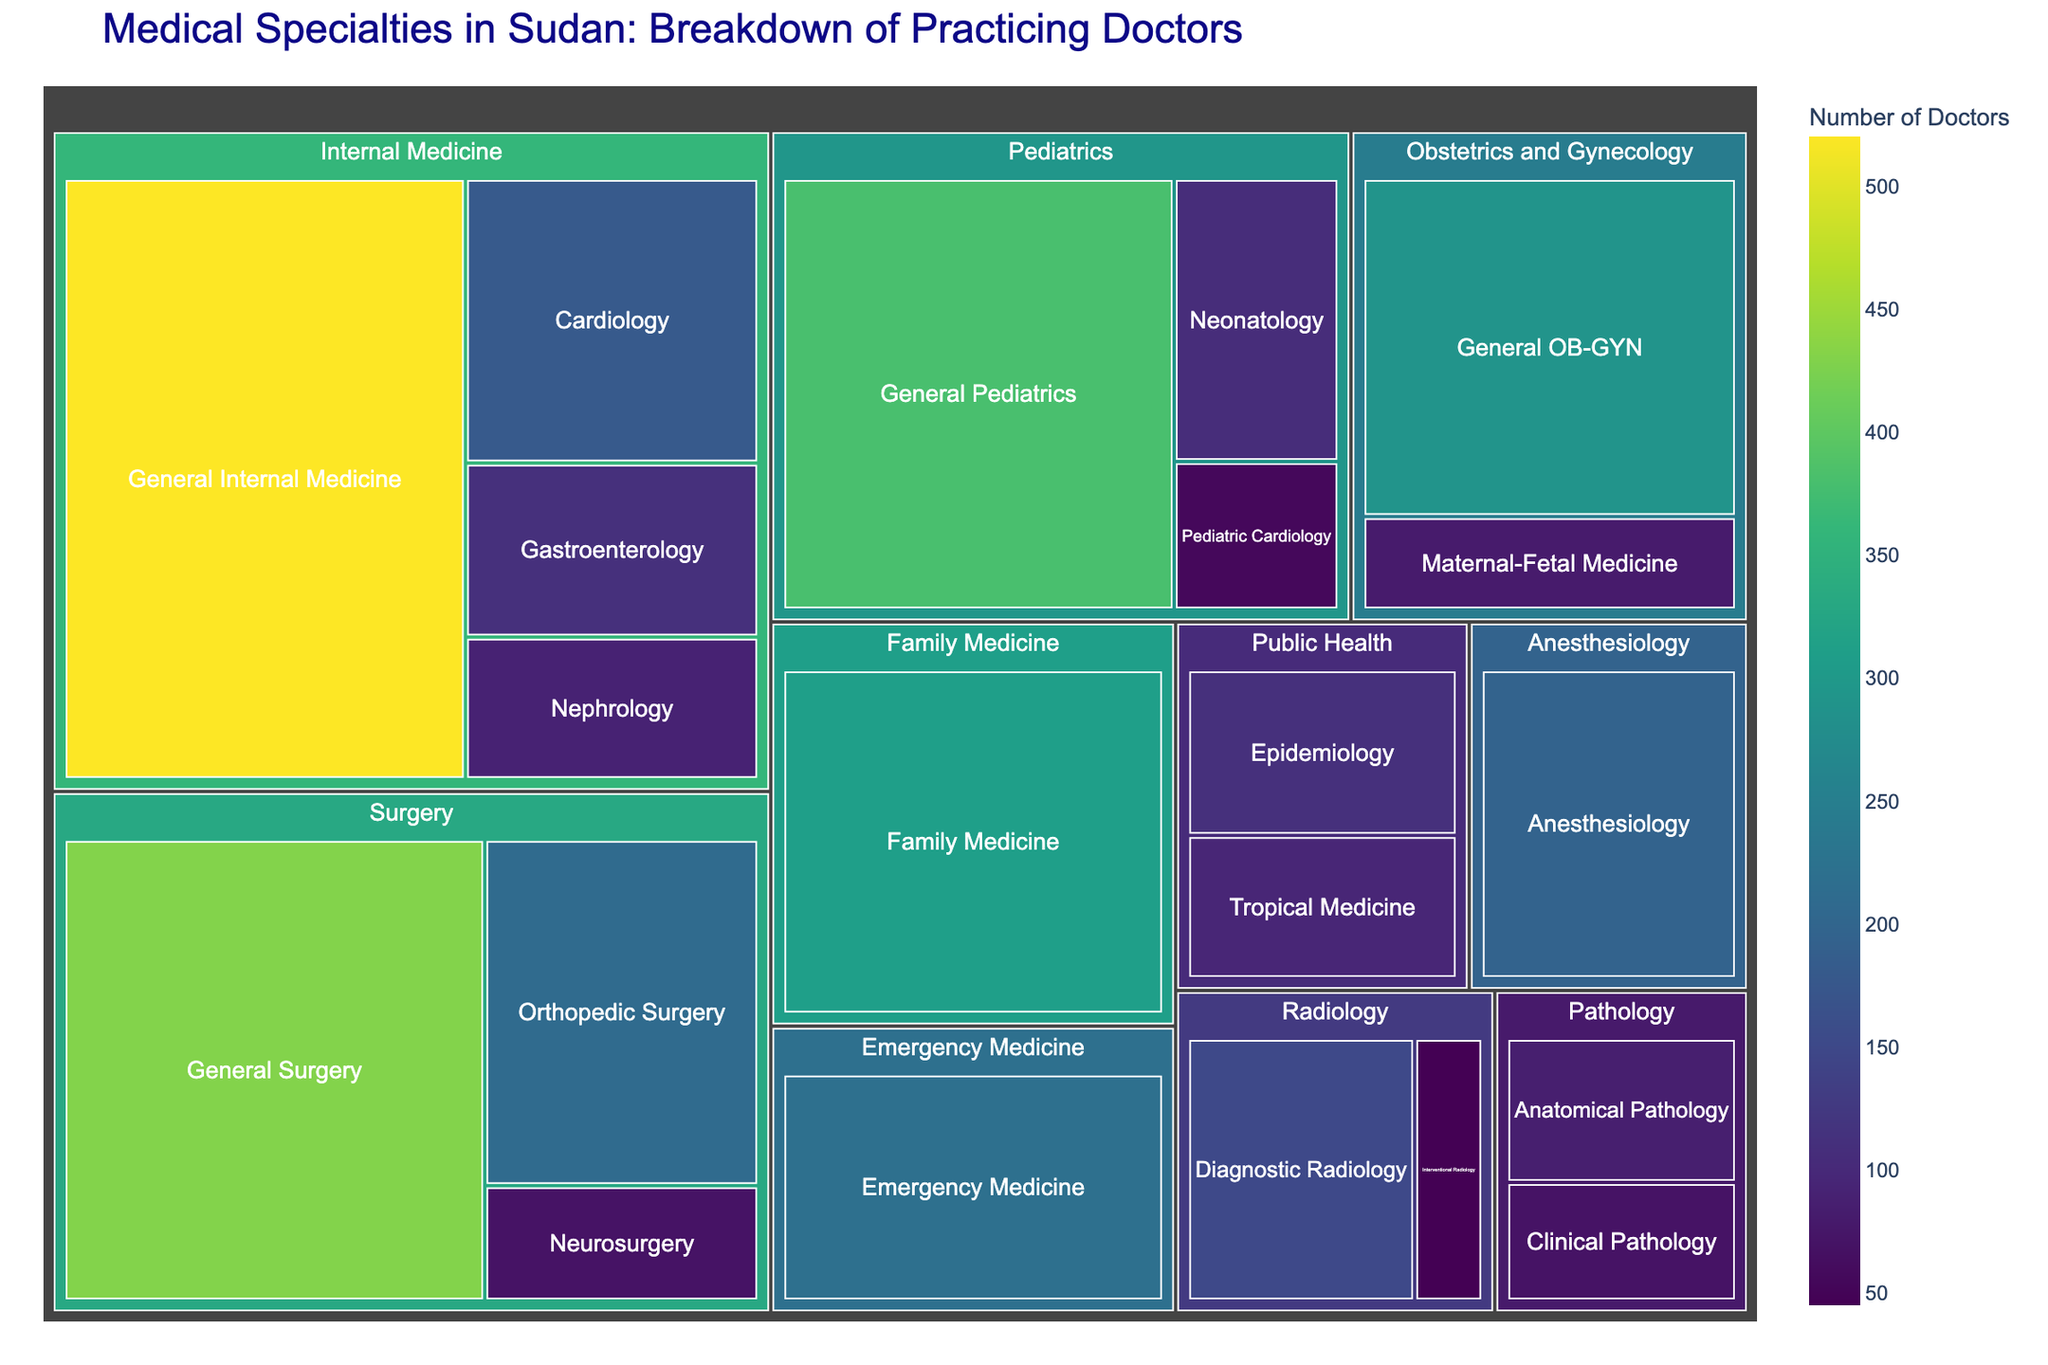What's the title of the treemap? The title is usually found at the top of the figure and serves to summarize the visual content. The title directly states what the figure represents.
Answer: Medical Specialties in Sudan: Breakdown of Practicing Doctors Which medical specialty has the highest number of doctors? You need to look for the largest segment or rectangle in the treemap that is labeled with a specialty. The size of each rectangle indicates the number of doctors.
Answer: Internal Medicine How many doctors practice Neonatology in Sudan? The treemap has a segment for Neonatology under the Pediatrics branch. Locate it and read the number shown.
Answer: 105 What is the total number of doctors practicing in the Surgery specialty? Sum the numbers of doctors in all subspecialties under Surgery: General Surgery, Orthopedic Surgery, Neurosurgery. The sum is 430 + 210 + 70 = 710.
Answer: 710 Which is larger: the number of doctors in Cardiology or Orthopedic Surgery? Compare the size of the Cardiology segment under Internal Medicine with the Orthopedic Surgery segment under Surgery. Cardiology has 180 and Orthopedic Surgery has 210.
Answer: Orthopedic Surgery How many more doctors practice General Pediatrics than Pediatric Cardiology? Subtract the number of Pediatric Cardiology doctors from General Pediatrics doctors: 380 - 55 = 325.
Answer: 325 What subspecialty of Radiology has fewer doctors? Look at the two subspecialties of Radiology and compare their numbers: Diagnostic Radiology has 150, while Interventional Radiology has 45.
Answer: Interventional Radiology Which specialty has the least number of practicing doctors? Identify the smallest segment in the treemap, which corresponds to the specialty with the least doctors. Compare all specialties to find that Interventional Radiology within Radiology (has 45) is part of the smallest, but the overall smallest specialty is Interventional Radiology.
Answer: Pathology What is the average number of doctors in the subspecialties of Internal Medicine? The subspecialties of Internal Medicine are General Internal Medicine, Cardiology, Gastroenterology, and Nephrology. Sum their doctors and divide by 4: (520 + 180 + 110 + 90) / 4 = 225.
Answer: 225 Which has more doctors, Family Medicine or Emergency Medicine? Compare the segments for Family Medicine and Emergency Medicine. Family Medicine has 310 doctors, while Emergency Medicine has 220.
Answer: Family Medicine 